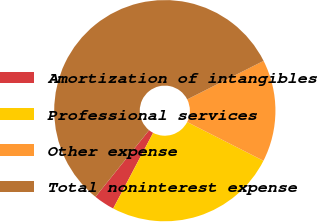Convert chart. <chart><loc_0><loc_0><loc_500><loc_500><pie_chart><fcel>Amortization of intangibles<fcel>Professional services<fcel>Other expense<fcel>Total noninterest expense<nl><fcel>3.06%<fcel>25.25%<fcel>14.91%<fcel>56.78%<nl></chart> 